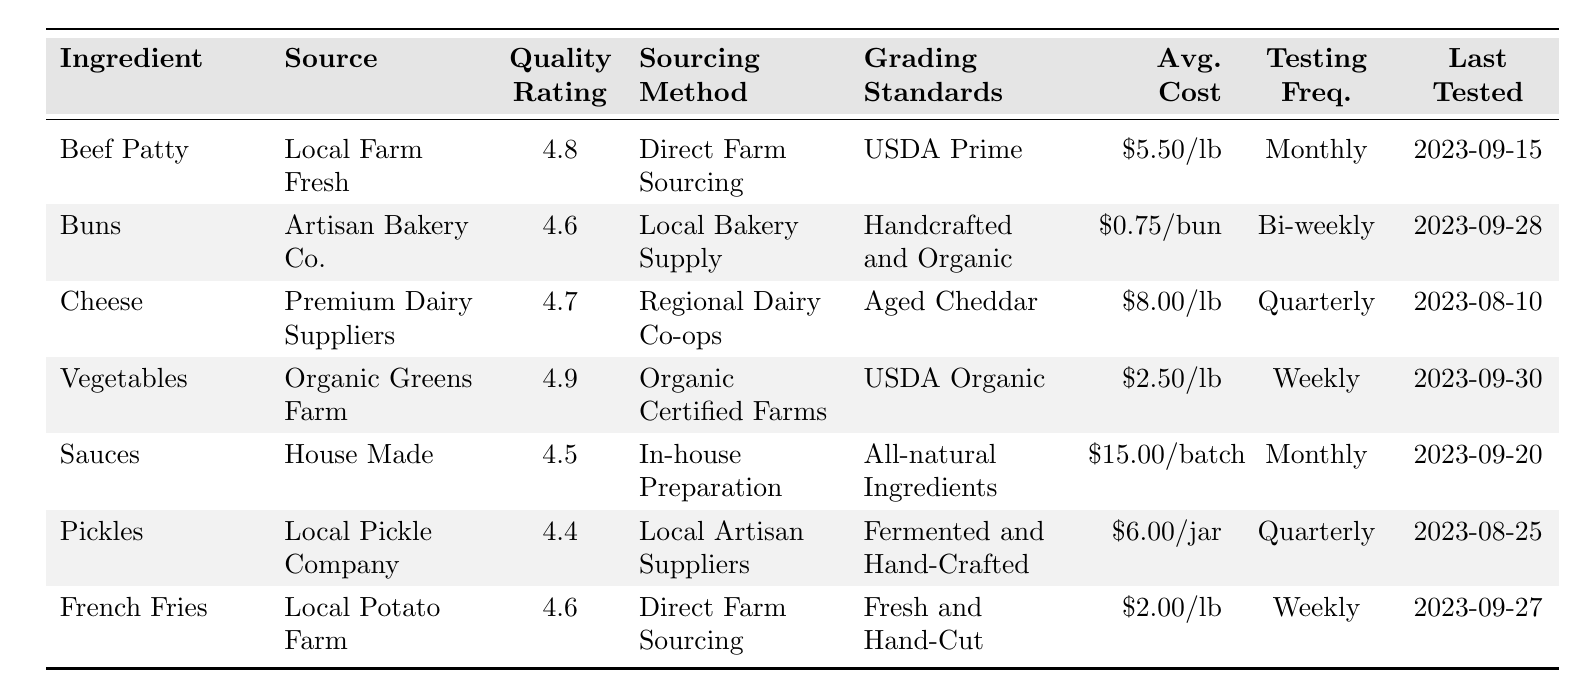What is the quality rating for the Beef Patty? The table shows the quality rating for the Beef Patty as 4.8.
Answer: 4.8 What is the average cost per lb of the Cheese? The table indicates that the average cost per lb of Cheese is $8.00.
Answer: $8.00 Which ingredient has the highest quality rating? By comparing the quality ratings, the Vegetables have the highest quality rating at 4.9.
Answer: Vegetables How often are the Buns tested for quality? The table states that Buns are tested bi-weekly.
Answer: Bi-weekly What is the average cost of Pickles per jar? The table lists the average cost of Pickles as $6.00 per jar.
Answer: $6.00 Is the sourcing method for Sauces in-house? The table confirms that the sourcing method for Sauces is in-house preparation, which means yes.
Answer: Yes What is the frequency of testing for the French Fries? According to the table, French Fries are tested weekly.
Answer: Weekly What is the total average cost of all ingredients listed in the table? To find the total, we sum up the individual average costs: $5.50 (Beef Patty) + $0.75 (Buns) + $8.00 (Cheese) + $2.50 (Vegetables) + $15.00 (Sauces) + $6.00 (Pickles) + $2.00 (French Fries) = $39.75.
Answer: $39.75 How does the quality rating of Cheese compare to Sauces? The quality rating of Cheese is 4.7, which is higher than the quality rating of Sauces at 4.5.
Answer: Higher What was the last tested date of the Vegetables? The last tested date for Vegetables, as per the table, is 2023-09-30.
Answer: 2023-09-30 If the average cost per lb of Beef Patty is $5.50 and it is tested monthly, how much would it cost for quality testing over six months? The total cost for six months would be $5.50 (cost per lb) x 6 = $33.00.
Answer: $33.00 